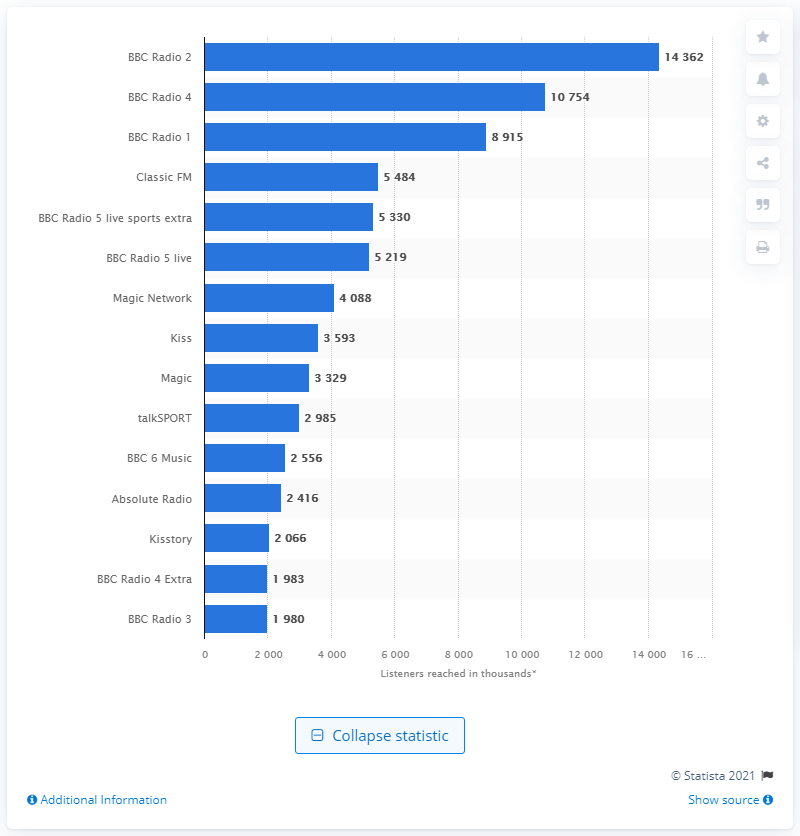Draw attention to some important aspects in this diagram. The predominant radio station in the United Kingdom is BBC Radio 2. 